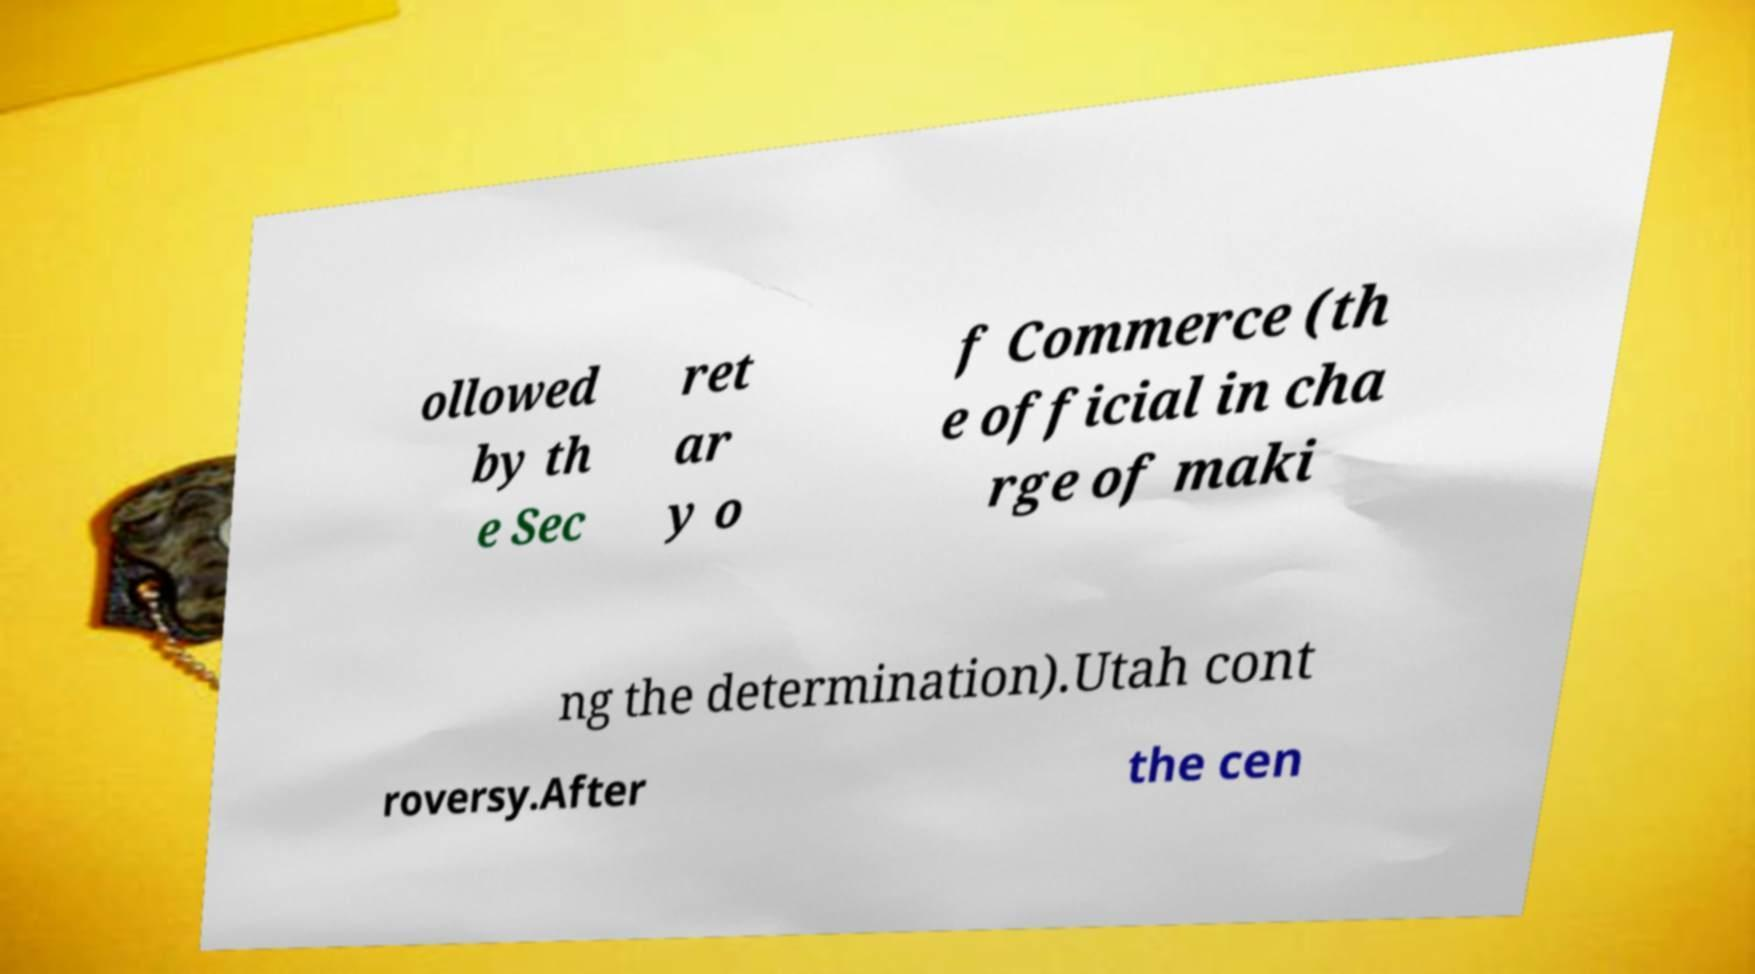Please identify and transcribe the text found in this image. ollowed by th e Sec ret ar y o f Commerce (th e official in cha rge of maki ng the determination).Utah cont roversy.After the cen 